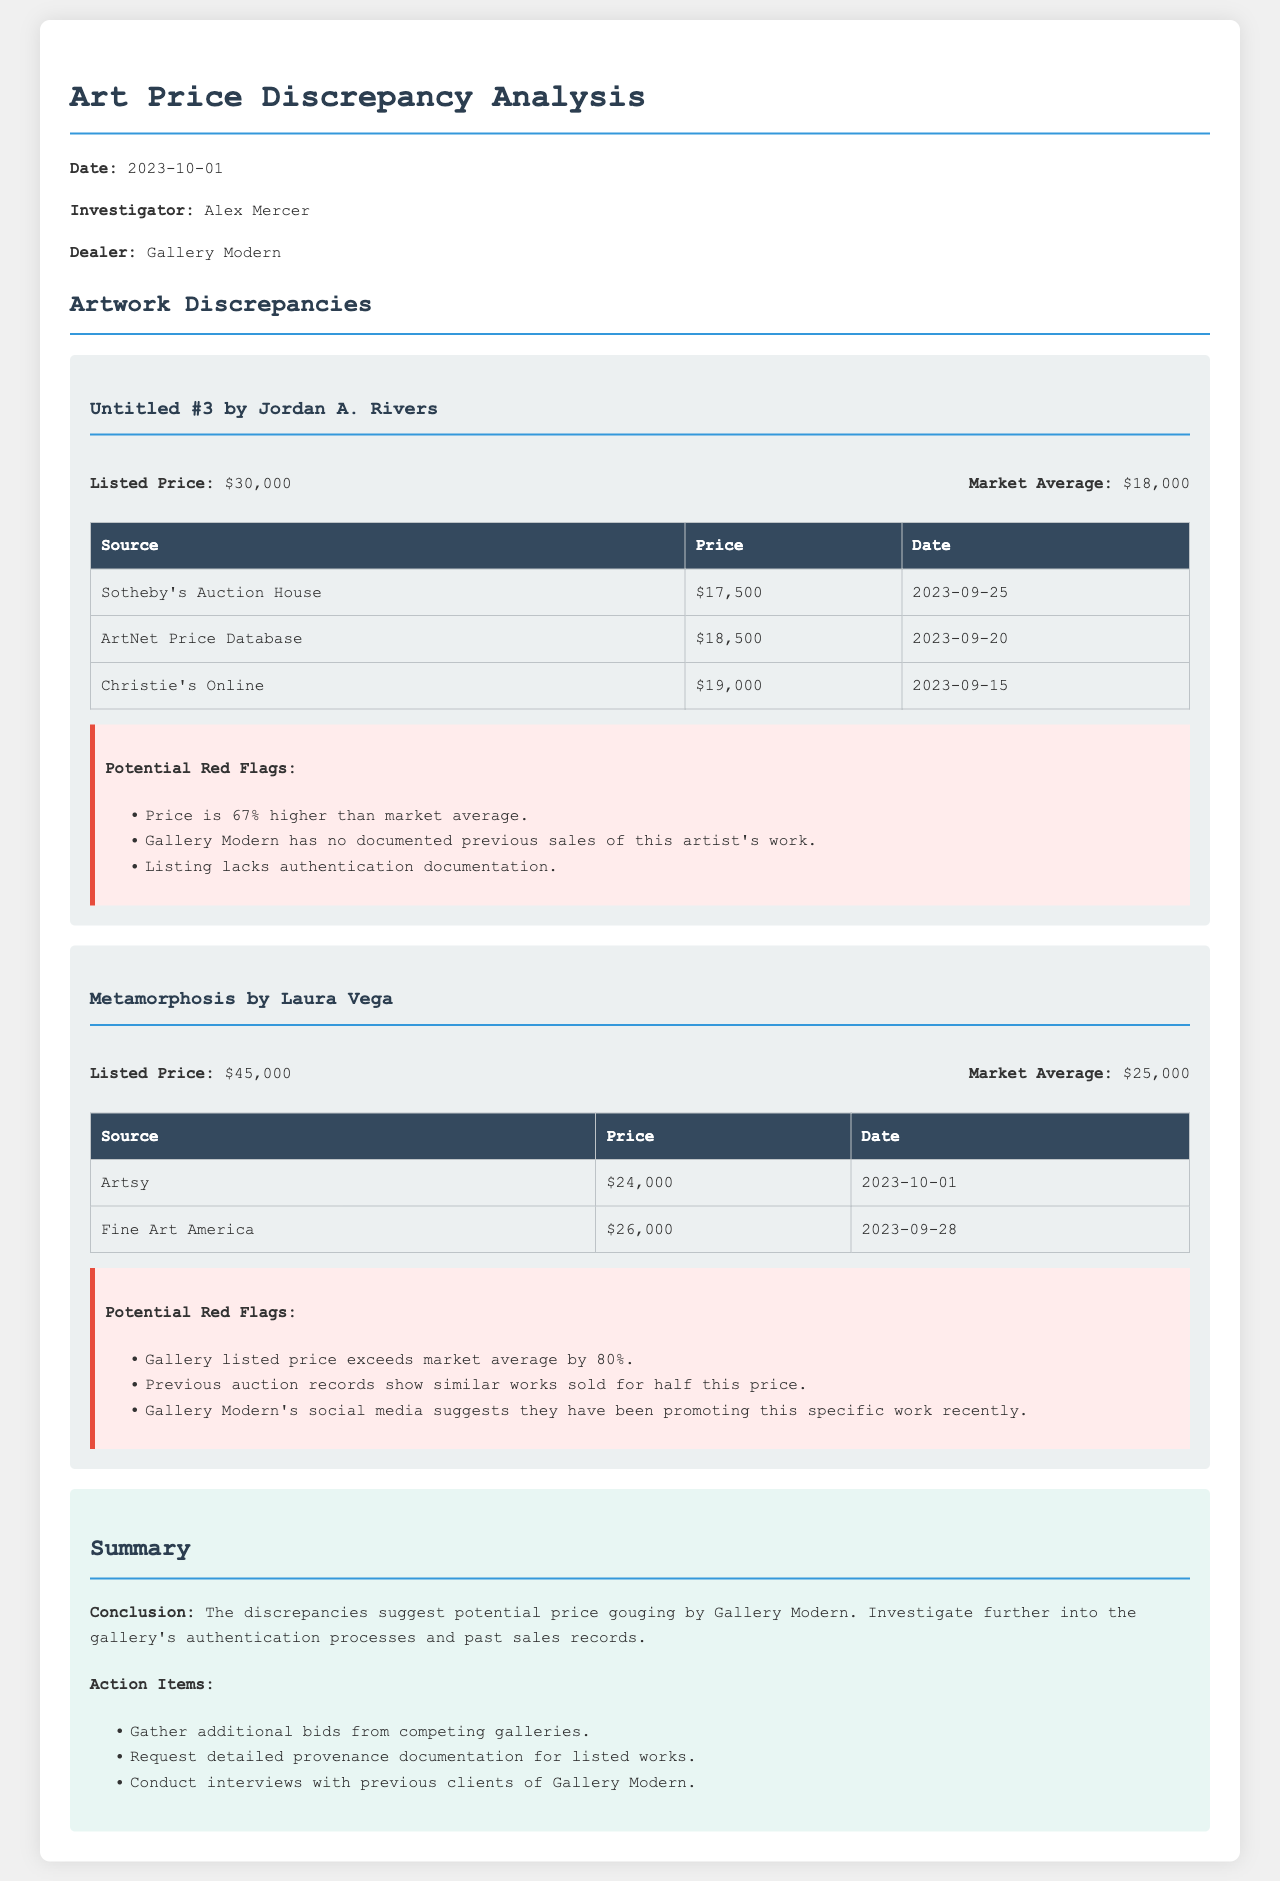What is the listed price of "Untitled #3"? The listed price is stated directly in the document as $30,000 for the artwork "Untitled #3".
Answer: $30,000 What is the market average price for "Metamorphosis"? The market average for "Metamorphosis" is clearly noted in the document as $25,000.
Answer: $25,000 How much higher is the listed price of "Untitled #3" compared to the market average? The document indicates that the listed price of $30,000 is 67% higher than the market average of $18,000.
Answer: 67% What is a potential red flag associated with "Metamorphosis"? The document outlines several potential red flags for "Metamorphosis," including that the gallery price exceeds the market average by 80%.
Answer: Exceeds by 80% Who is the dealer mentioned in the analysis? The document specifies that the dealer being analyzed is Gallery Modern.
Answer: Gallery Modern When was the analysis conducted? The date of the analysis is explicitly mentioned as October 1, 2023.
Answer: October 1, 2023 What auction house reported a price for "Untitled #3"? The document lists Sotheby's Auction House as one of the sources for pricing on "Untitled #3".
Answer: Sotheby's Auction House What is the price reported by Fine Art America for "Metamorphosis"? Fine Art America is noted in the document as reporting a price of $26,000 for "Metamorphosis".
Answer: $26,000 